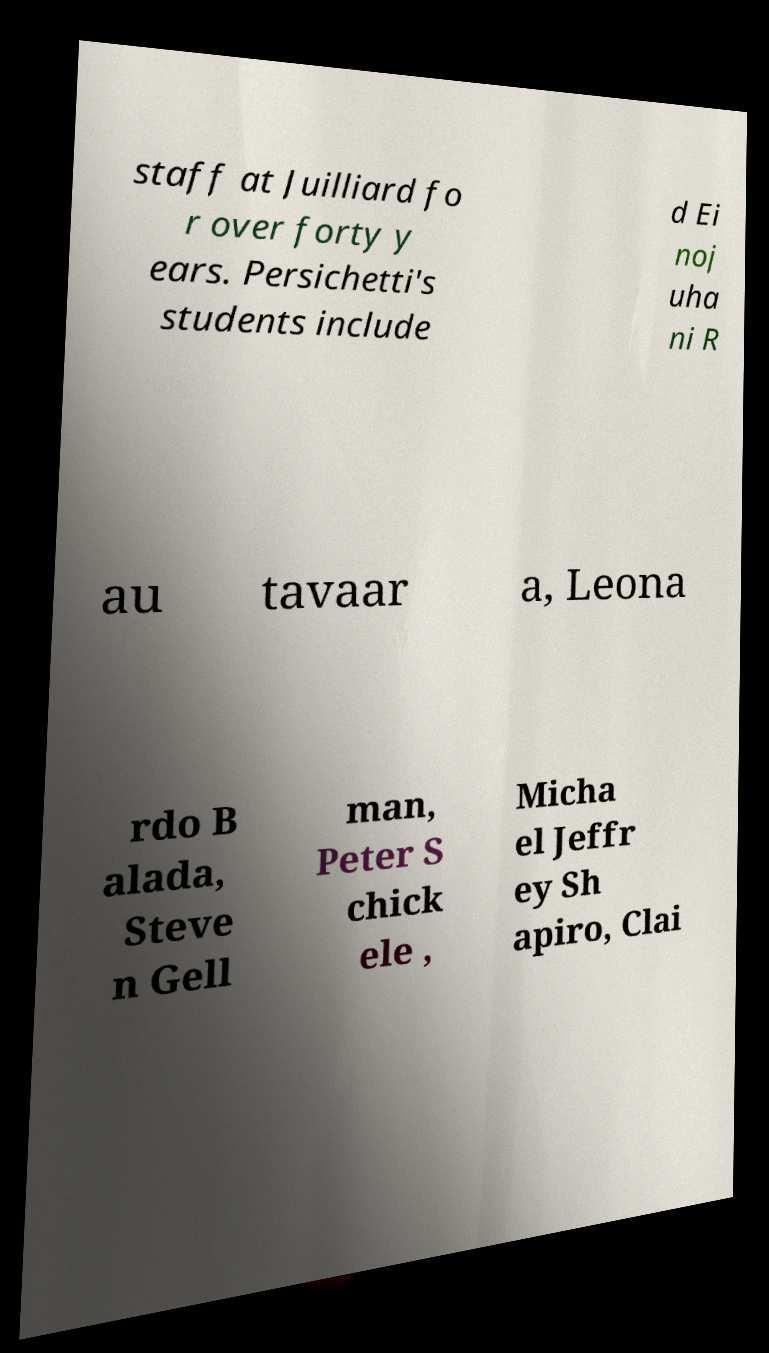Could you assist in decoding the text presented in this image and type it out clearly? staff at Juilliard fo r over forty y ears. Persichetti's students include d Ei noj uha ni R au tavaar a, Leona rdo B alada, Steve n Gell man, Peter S chick ele , Micha el Jeffr ey Sh apiro, Clai 